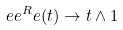Convert formula to latex. <formula><loc_0><loc_0><loc_500><loc_500>\ e e ^ { R } _ { \ } e ( t ) \to t \land 1</formula> 